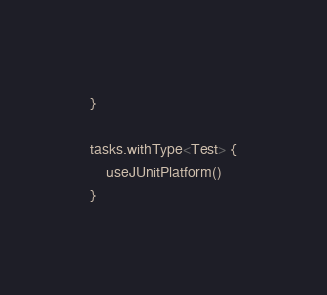Convert code to text. <code><loc_0><loc_0><loc_500><loc_500><_Kotlin_>}

tasks.withType<Test> {
    useJUnitPlatform()
}</code> 